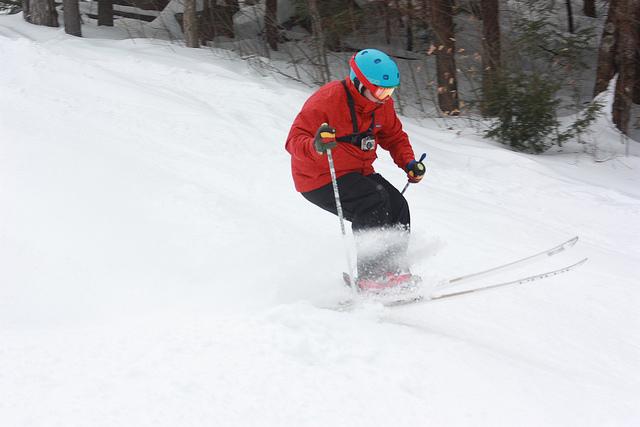Are the front tips of the man's skis in the snow?
Answer briefly. No. What color are the skis?
Give a very brief answer. White. What color is the helmet?
Be succinct. Blue. Is this skier performing a trick?
Be succinct. No. 